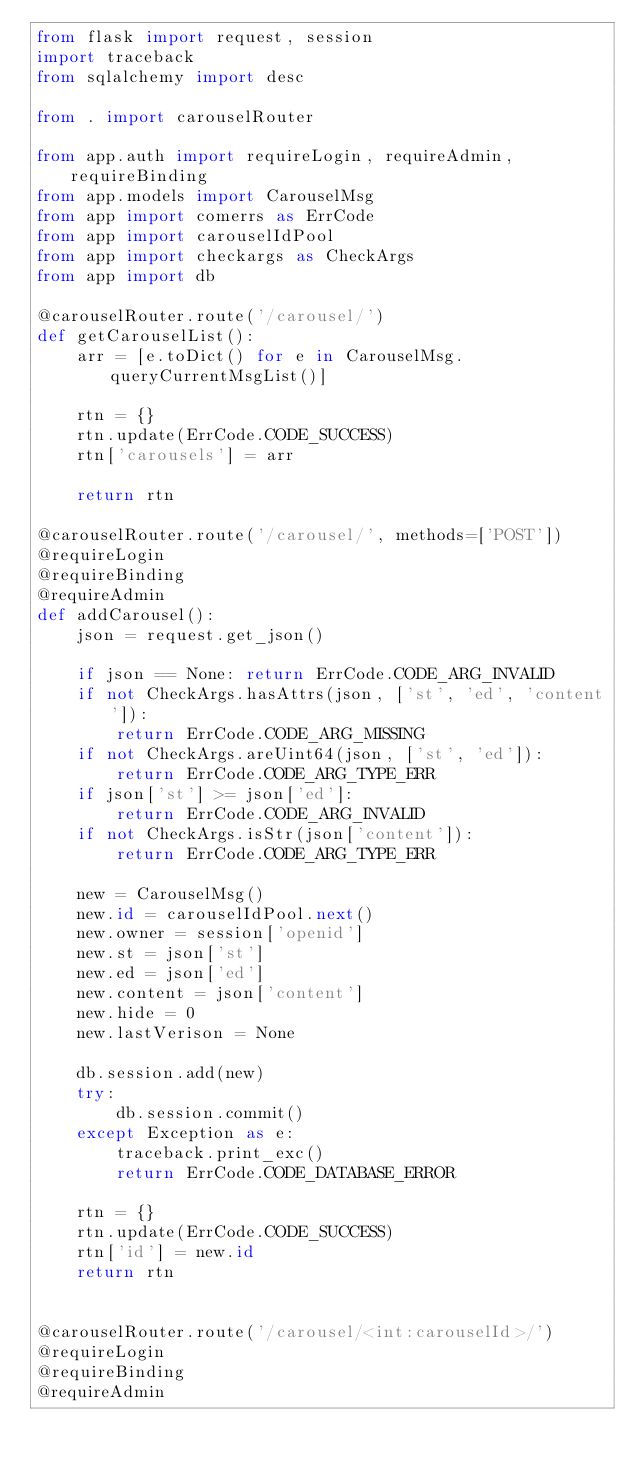<code> <loc_0><loc_0><loc_500><loc_500><_Python_>from flask import request, session
import traceback
from sqlalchemy import desc

from . import carouselRouter

from app.auth import requireLogin, requireAdmin, requireBinding
from app.models import CarouselMsg
from app import comerrs as ErrCode
from app import carouselIdPool
from app import checkargs as CheckArgs
from app import db

@carouselRouter.route('/carousel/')
def getCarouselList():
    arr = [e.toDict() for e in CarouselMsg.queryCurrentMsgList()]

    rtn = {}
    rtn.update(ErrCode.CODE_SUCCESS)
    rtn['carousels'] = arr

    return rtn

@carouselRouter.route('/carousel/', methods=['POST'])
@requireLogin
@requireBinding
@requireAdmin
def addCarousel():
    json = request.get_json()

    if json == None: return ErrCode.CODE_ARG_INVALID
    if not CheckArgs.hasAttrs(json, ['st', 'ed', 'content']):
        return ErrCode.CODE_ARG_MISSING
    if not CheckArgs.areUint64(json, ['st', 'ed']):
        return ErrCode.CODE_ARG_TYPE_ERR
    if json['st'] >= json['ed']:
        return ErrCode.CODE_ARG_INVALID
    if not CheckArgs.isStr(json['content']):
        return ErrCode.CODE_ARG_TYPE_ERR

    new = CarouselMsg()
    new.id = carouselIdPool.next()
    new.owner = session['openid']
    new.st = json['st']
    new.ed = json['ed']
    new.content = json['content']
    new.hide = 0
    new.lastVerison = None

    db.session.add(new)
    try:
        db.session.commit()
    except Exception as e:
        traceback.print_exc()
        return ErrCode.CODE_DATABASE_ERROR

    rtn = {}
    rtn.update(ErrCode.CODE_SUCCESS)
    rtn['id'] = new.id
    return rtn


@carouselRouter.route('/carousel/<int:carouselId>/')
@requireLogin
@requireBinding
@requireAdmin</code> 